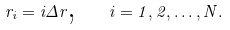<formula> <loc_0><loc_0><loc_500><loc_500>r _ { i } = i \Delta r \text {, \ \ } i = 1 , 2 , \dots , N .</formula> 